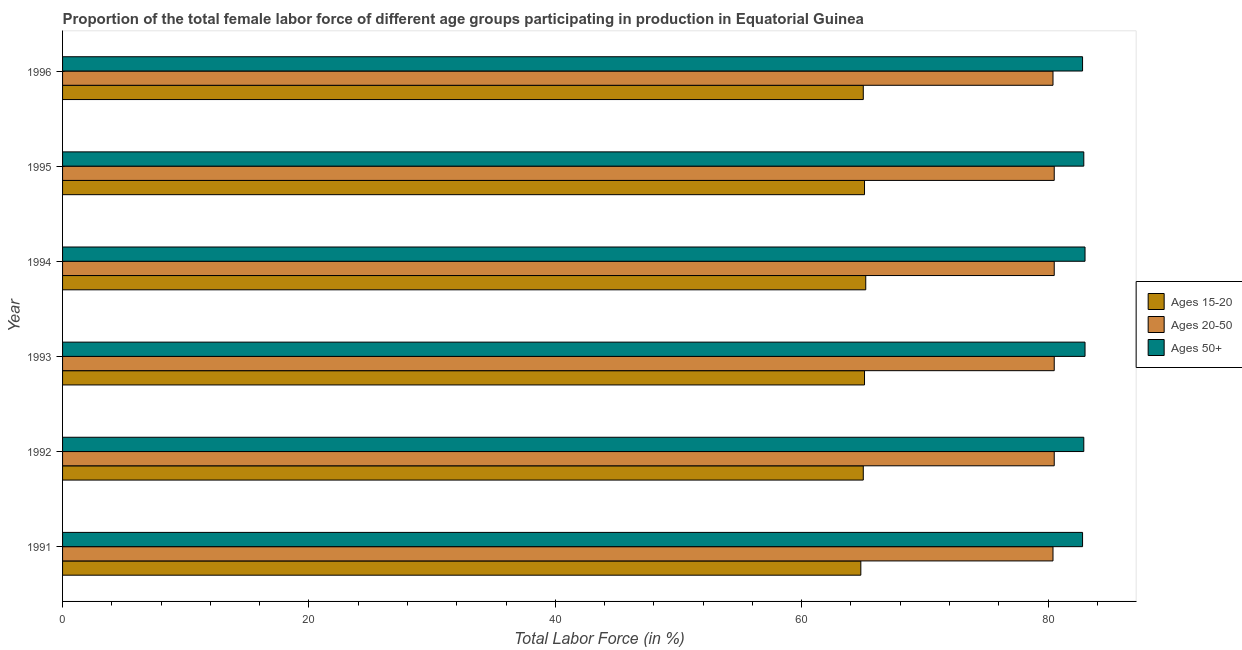How many different coloured bars are there?
Give a very brief answer. 3. How many groups of bars are there?
Keep it short and to the point. 6. Are the number of bars per tick equal to the number of legend labels?
Give a very brief answer. Yes. Are the number of bars on each tick of the Y-axis equal?
Your answer should be very brief. Yes. How many bars are there on the 2nd tick from the top?
Offer a very short reply. 3. What is the label of the 3rd group of bars from the top?
Your answer should be compact. 1994. What is the percentage of female labor force above age 50 in 1996?
Your answer should be compact. 82.8. Across all years, what is the maximum percentage of female labor force above age 50?
Keep it short and to the point. 83. Across all years, what is the minimum percentage of female labor force within the age group 20-50?
Keep it short and to the point. 80.4. In which year was the percentage of female labor force within the age group 20-50 maximum?
Offer a very short reply. 1992. What is the total percentage of female labor force within the age group 15-20 in the graph?
Offer a very short reply. 390.2. What is the difference between the percentage of female labor force within the age group 15-20 in 1991 and that in 1993?
Provide a short and direct response. -0.3. What is the difference between the percentage of female labor force within the age group 15-20 in 1991 and the percentage of female labor force above age 50 in 1993?
Your answer should be very brief. -18.2. What is the average percentage of female labor force within the age group 20-50 per year?
Keep it short and to the point. 80.47. In the year 1994, what is the difference between the percentage of female labor force within the age group 15-20 and percentage of female labor force above age 50?
Keep it short and to the point. -17.8. What is the ratio of the percentage of female labor force above age 50 in 1994 to that in 1995?
Offer a very short reply. 1. Is the difference between the percentage of female labor force within the age group 15-20 in 1994 and 1995 greater than the difference between the percentage of female labor force within the age group 20-50 in 1994 and 1995?
Make the answer very short. Yes. What is the difference between the highest and the lowest percentage of female labor force within the age group 20-50?
Provide a short and direct response. 0.1. What does the 3rd bar from the top in 1993 represents?
Offer a terse response. Ages 15-20. What does the 1st bar from the bottom in 1996 represents?
Give a very brief answer. Ages 15-20. Are all the bars in the graph horizontal?
Provide a short and direct response. Yes. How many years are there in the graph?
Make the answer very short. 6. What is the difference between two consecutive major ticks on the X-axis?
Make the answer very short. 20. Where does the legend appear in the graph?
Give a very brief answer. Center right. How many legend labels are there?
Make the answer very short. 3. What is the title of the graph?
Make the answer very short. Proportion of the total female labor force of different age groups participating in production in Equatorial Guinea. What is the Total Labor Force (in %) of Ages 15-20 in 1991?
Make the answer very short. 64.8. What is the Total Labor Force (in %) in Ages 20-50 in 1991?
Provide a succinct answer. 80.4. What is the Total Labor Force (in %) of Ages 50+ in 1991?
Your answer should be very brief. 82.8. What is the Total Labor Force (in %) in Ages 15-20 in 1992?
Your answer should be compact. 65. What is the Total Labor Force (in %) in Ages 20-50 in 1992?
Offer a very short reply. 80.5. What is the Total Labor Force (in %) in Ages 50+ in 1992?
Your answer should be very brief. 82.9. What is the Total Labor Force (in %) of Ages 15-20 in 1993?
Give a very brief answer. 65.1. What is the Total Labor Force (in %) of Ages 20-50 in 1993?
Offer a terse response. 80.5. What is the Total Labor Force (in %) in Ages 50+ in 1993?
Keep it short and to the point. 83. What is the Total Labor Force (in %) of Ages 15-20 in 1994?
Provide a short and direct response. 65.2. What is the Total Labor Force (in %) in Ages 20-50 in 1994?
Ensure brevity in your answer.  80.5. What is the Total Labor Force (in %) of Ages 50+ in 1994?
Provide a short and direct response. 83. What is the Total Labor Force (in %) of Ages 15-20 in 1995?
Your answer should be compact. 65.1. What is the Total Labor Force (in %) of Ages 20-50 in 1995?
Your answer should be compact. 80.5. What is the Total Labor Force (in %) of Ages 50+ in 1995?
Make the answer very short. 82.9. What is the Total Labor Force (in %) of Ages 20-50 in 1996?
Make the answer very short. 80.4. What is the Total Labor Force (in %) in Ages 50+ in 1996?
Your response must be concise. 82.8. Across all years, what is the maximum Total Labor Force (in %) of Ages 15-20?
Your answer should be compact. 65.2. Across all years, what is the maximum Total Labor Force (in %) in Ages 20-50?
Make the answer very short. 80.5. Across all years, what is the maximum Total Labor Force (in %) in Ages 50+?
Give a very brief answer. 83. Across all years, what is the minimum Total Labor Force (in %) of Ages 15-20?
Provide a short and direct response. 64.8. Across all years, what is the minimum Total Labor Force (in %) in Ages 20-50?
Offer a terse response. 80.4. Across all years, what is the minimum Total Labor Force (in %) of Ages 50+?
Provide a short and direct response. 82.8. What is the total Total Labor Force (in %) of Ages 15-20 in the graph?
Make the answer very short. 390.2. What is the total Total Labor Force (in %) of Ages 20-50 in the graph?
Give a very brief answer. 482.8. What is the total Total Labor Force (in %) in Ages 50+ in the graph?
Offer a very short reply. 497.4. What is the difference between the Total Labor Force (in %) of Ages 50+ in 1991 and that in 1992?
Offer a very short reply. -0.1. What is the difference between the Total Labor Force (in %) in Ages 50+ in 1991 and that in 1993?
Give a very brief answer. -0.2. What is the difference between the Total Labor Force (in %) in Ages 15-20 in 1991 and that in 1994?
Offer a very short reply. -0.4. What is the difference between the Total Labor Force (in %) of Ages 50+ in 1991 and that in 1994?
Offer a very short reply. -0.2. What is the difference between the Total Labor Force (in %) in Ages 15-20 in 1991 and that in 1996?
Provide a succinct answer. -0.2. What is the difference between the Total Labor Force (in %) in Ages 20-50 in 1991 and that in 1996?
Offer a very short reply. 0. What is the difference between the Total Labor Force (in %) of Ages 50+ in 1991 and that in 1996?
Your answer should be very brief. 0. What is the difference between the Total Labor Force (in %) in Ages 15-20 in 1992 and that in 1993?
Your answer should be very brief. -0.1. What is the difference between the Total Labor Force (in %) in Ages 15-20 in 1992 and that in 1994?
Offer a terse response. -0.2. What is the difference between the Total Labor Force (in %) in Ages 20-50 in 1992 and that in 1994?
Ensure brevity in your answer.  0. What is the difference between the Total Labor Force (in %) in Ages 50+ in 1992 and that in 1994?
Your response must be concise. -0.1. What is the difference between the Total Labor Force (in %) of Ages 15-20 in 1992 and that in 1995?
Your response must be concise. -0.1. What is the difference between the Total Labor Force (in %) of Ages 20-50 in 1992 and that in 1995?
Provide a short and direct response. 0. What is the difference between the Total Labor Force (in %) of Ages 50+ in 1992 and that in 1995?
Offer a very short reply. 0. What is the difference between the Total Labor Force (in %) in Ages 15-20 in 1992 and that in 1996?
Offer a terse response. 0. What is the difference between the Total Labor Force (in %) of Ages 50+ in 1993 and that in 1995?
Your answer should be compact. 0.1. What is the difference between the Total Labor Force (in %) in Ages 15-20 in 1993 and that in 1996?
Offer a very short reply. 0.1. What is the difference between the Total Labor Force (in %) in Ages 20-50 in 1993 and that in 1996?
Keep it short and to the point. 0.1. What is the difference between the Total Labor Force (in %) of Ages 20-50 in 1994 and that in 1995?
Your answer should be compact. 0. What is the difference between the Total Labor Force (in %) of Ages 50+ in 1994 and that in 1996?
Provide a succinct answer. 0.2. What is the difference between the Total Labor Force (in %) of Ages 20-50 in 1995 and that in 1996?
Keep it short and to the point. 0.1. What is the difference between the Total Labor Force (in %) of Ages 50+ in 1995 and that in 1996?
Provide a succinct answer. 0.1. What is the difference between the Total Labor Force (in %) of Ages 15-20 in 1991 and the Total Labor Force (in %) of Ages 20-50 in 1992?
Offer a terse response. -15.7. What is the difference between the Total Labor Force (in %) in Ages 15-20 in 1991 and the Total Labor Force (in %) in Ages 50+ in 1992?
Ensure brevity in your answer.  -18.1. What is the difference between the Total Labor Force (in %) in Ages 15-20 in 1991 and the Total Labor Force (in %) in Ages 20-50 in 1993?
Your response must be concise. -15.7. What is the difference between the Total Labor Force (in %) in Ages 15-20 in 1991 and the Total Labor Force (in %) in Ages 50+ in 1993?
Ensure brevity in your answer.  -18.2. What is the difference between the Total Labor Force (in %) in Ages 15-20 in 1991 and the Total Labor Force (in %) in Ages 20-50 in 1994?
Ensure brevity in your answer.  -15.7. What is the difference between the Total Labor Force (in %) of Ages 15-20 in 1991 and the Total Labor Force (in %) of Ages 50+ in 1994?
Make the answer very short. -18.2. What is the difference between the Total Labor Force (in %) of Ages 15-20 in 1991 and the Total Labor Force (in %) of Ages 20-50 in 1995?
Provide a succinct answer. -15.7. What is the difference between the Total Labor Force (in %) of Ages 15-20 in 1991 and the Total Labor Force (in %) of Ages 50+ in 1995?
Your response must be concise. -18.1. What is the difference between the Total Labor Force (in %) in Ages 15-20 in 1991 and the Total Labor Force (in %) in Ages 20-50 in 1996?
Keep it short and to the point. -15.6. What is the difference between the Total Labor Force (in %) of Ages 20-50 in 1991 and the Total Labor Force (in %) of Ages 50+ in 1996?
Keep it short and to the point. -2.4. What is the difference between the Total Labor Force (in %) of Ages 15-20 in 1992 and the Total Labor Force (in %) of Ages 20-50 in 1993?
Offer a very short reply. -15.5. What is the difference between the Total Labor Force (in %) in Ages 20-50 in 1992 and the Total Labor Force (in %) in Ages 50+ in 1993?
Keep it short and to the point. -2.5. What is the difference between the Total Labor Force (in %) of Ages 15-20 in 1992 and the Total Labor Force (in %) of Ages 20-50 in 1994?
Provide a succinct answer. -15.5. What is the difference between the Total Labor Force (in %) in Ages 20-50 in 1992 and the Total Labor Force (in %) in Ages 50+ in 1994?
Give a very brief answer. -2.5. What is the difference between the Total Labor Force (in %) of Ages 15-20 in 1992 and the Total Labor Force (in %) of Ages 20-50 in 1995?
Make the answer very short. -15.5. What is the difference between the Total Labor Force (in %) in Ages 15-20 in 1992 and the Total Labor Force (in %) in Ages 50+ in 1995?
Your answer should be very brief. -17.9. What is the difference between the Total Labor Force (in %) in Ages 15-20 in 1992 and the Total Labor Force (in %) in Ages 20-50 in 1996?
Provide a short and direct response. -15.4. What is the difference between the Total Labor Force (in %) of Ages 15-20 in 1992 and the Total Labor Force (in %) of Ages 50+ in 1996?
Provide a succinct answer. -17.8. What is the difference between the Total Labor Force (in %) of Ages 15-20 in 1993 and the Total Labor Force (in %) of Ages 20-50 in 1994?
Provide a short and direct response. -15.4. What is the difference between the Total Labor Force (in %) of Ages 15-20 in 1993 and the Total Labor Force (in %) of Ages 50+ in 1994?
Keep it short and to the point. -17.9. What is the difference between the Total Labor Force (in %) of Ages 15-20 in 1993 and the Total Labor Force (in %) of Ages 20-50 in 1995?
Your answer should be very brief. -15.4. What is the difference between the Total Labor Force (in %) in Ages 15-20 in 1993 and the Total Labor Force (in %) in Ages 50+ in 1995?
Keep it short and to the point. -17.8. What is the difference between the Total Labor Force (in %) of Ages 20-50 in 1993 and the Total Labor Force (in %) of Ages 50+ in 1995?
Ensure brevity in your answer.  -2.4. What is the difference between the Total Labor Force (in %) of Ages 15-20 in 1993 and the Total Labor Force (in %) of Ages 20-50 in 1996?
Offer a very short reply. -15.3. What is the difference between the Total Labor Force (in %) of Ages 15-20 in 1993 and the Total Labor Force (in %) of Ages 50+ in 1996?
Your answer should be compact. -17.7. What is the difference between the Total Labor Force (in %) of Ages 20-50 in 1993 and the Total Labor Force (in %) of Ages 50+ in 1996?
Make the answer very short. -2.3. What is the difference between the Total Labor Force (in %) of Ages 15-20 in 1994 and the Total Labor Force (in %) of Ages 20-50 in 1995?
Offer a very short reply. -15.3. What is the difference between the Total Labor Force (in %) of Ages 15-20 in 1994 and the Total Labor Force (in %) of Ages 50+ in 1995?
Make the answer very short. -17.7. What is the difference between the Total Labor Force (in %) of Ages 15-20 in 1994 and the Total Labor Force (in %) of Ages 20-50 in 1996?
Keep it short and to the point. -15.2. What is the difference between the Total Labor Force (in %) of Ages 15-20 in 1994 and the Total Labor Force (in %) of Ages 50+ in 1996?
Provide a short and direct response. -17.6. What is the difference between the Total Labor Force (in %) in Ages 15-20 in 1995 and the Total Labor Force (in %) in Ages 20-50 in 1996?
Your answer should be compact. -15.3. What is the difference between the Total Labor Force (in %) of Ages 15-20 in 1995 and the Total Labor Force (in %) of Ages 50+ in 1996?
Make the answer very short. -17.7. What is the difference between the Total Labor Force (in %) of Ages 20-50 in 1995 and the Total Labor Force (in %) of Ages 50+ in 1996?
Make the answer very short. -2.3. What is the average Total Labor Force (in %) in Ages 15-20 per year?
Your answer should be very brief. 65.03. What is the average Total Labor Force (in %) in Ages 20-50 per year?
Provide a short and direct response. 80.47. What is the average Total Labor Force (in %) of Ages 50+ per year?
Keep it short and to the point. 82.9. In the year 1991, what is the difference between the Total Labor Force (in %) of Ages 15-20 and Total Labor Force (in %) of Ages 20-50?
Provide a succinct answer. -15.6. In the year 1992, what is the difference between the Total Labor Force (in %) of Ages 15-20 and Total Labor Force (in %) of Ages 20-50?
Your response must be concise. -15.5. In the year 1992, what is the difference between the Total Labor Force (in %) in Ages 15-20 and Total Labor Force (in %) in Ages 50+?
Your answer should be compact. -17.9. In the year 1992, what is the difference between the Total Labor Force (in %) in Ages 20-50 and Total Labor Force (in %) in Ages 50+?
Make the answer very short. -2.4. In the year 1993, what is the difference between the Total Labor Force (in %) in Ages 15-20 and Total Labor Force (in %) in Ages 20-50?
Give a very brief answer. -15.4. In the year 1993, what is the difference between the Total Labor Force (in %) in Ages 15-20 and Total Labor Force (in %) in Ages 50+?
Offer a very short reply. -17.9. In the year 1994, what is the difference between the Total Labor Force (in %) in Ages 15-20 and Total Labor Force (in %) in Ages 20-50?
Your response must be concise. -15.3. In the year 1994, what is the difference between the Total Labor Force (in %) in Ages 15-20 and Total Labor Force (in %) in Ages 50+?
Offer a very short reply. -17.8. In the year 1995, what is the difference between the Total Labor Force (in %) in Ages 15-20 and Total Labor Force (in %) in Ages 20-50?
Provide a short and direct response. -15.4. In the year 1995, what is the difference between the Total Labor Force (in %) in Ages 15-20 and Total Labor Force (in %) in Ages 50+?
Make the answer very short. -17.8. In the year 1996, what is the difference between the Total Labor Force (in %) of Ages 15-20 and Total Labor Force (in %) of Ages 20-50?
Your answer should be very brief. -15.4. In the year 1996, what is the difference between the Total Labor Force (in %) in Ages 15-20 and Total Labor Force (in %) in Ages 50+?
Keep it short and to the point. -17.8. In the year 1996, what is the difference between the Total Labor Force (in %) in Ages 20-50 and Total Labor Force (in %) in Ages 50+?
Offer a very short reply. -2.4. What is the ratio of the Total Labor Force (in %) in Ages 15-20 in 1991 to that in 1992?
Make the answer very short. 1. What is the ratio of the Total Labor Force (in %) in Ages 15-20 in 1991 to that in 1993?
Your response must be concise. 1. What is the ratio of the Total Labor Force (in %) in Ages 20-50 in 1991 to that in 1993?
Offer a very short reply. 1. What is the ratio of the Total Labor Force (in %) of Ages 50+ in 1991 to that in 1993?
Offer a terse response. 1. What is the ratio of the Total Labor Force (in %) in Ages 50+ in 1991 to that in 1995?
Ensure brevity in your answer.  1. What is the ratio of the Total Labor Force (in %) of Ages 15-20 in 1991 to that in 1996?
Keep it short and to the point. 1. What is the ratio of the Total Labor Force (in %) in Ages 20-50 in 1991 to that in 1996?
Ensure brevity in your answer.  1. What is the ratio of the Total Labor Force (in %) of Ages 15-20 in 1992 to that in 1995?
Ensure brevity in your answer.  1. What is the ratio of the Total Labor Force (in %) in Ages 20-50 in 1992 to that in 1995?
Keep it short and to the point. 1. What is the ratio of the Total Labor Force (in %) in Ages 50+ in 1992 to that in 1995?
Your answer should be very brief. 1. What is the ratio of the Total Labor Force (in %) of Ages 15-20 in 1992 to that in 1996?
Make the answer very short. 1. What is the ratio of the Total Labor Force (in %) of Ages 15-20 in 1993 to that in 1994?
Your response must be concise. 1. What is the ratio of the Total Labor Force (in %) of Ages 20-50 in 1993 to that in 1994?
Give a very brief answer. 1. What is the ratio of the Total Labor Force (in %) in Ages 50+ in 1993 to that in 1994?
Offer a terse response. 1. What is the ratio of the Total Labor Force (in %) of Ages 20-50 in 1993 to that in 1995?
Make the answer very short. 1. What is the ratio of the Total Labor Force (in %) of Ages 20-50 in 1993 to that in 1996?
Offer a terse response. 1. What is the ratio of the Total Labor Force (in %) of Ages 50+ in 1994 to that in 1995?
Your answer should be very brief. 1. What is the ratio of the Total Labor Force (in %) of Ages 15-20 in 1994 to that in 1996?
Your answer should be very brief. 1. What is the ratio of the Total Labor Force (in %) in Ages 20-50 in 1994 to that in 1996?
Keep it short and to the point. 1. What is the ratio of the Total Labor Force (in %) in Ages 50+ in 1994 to that in 1996?
Keep it short and to the point. 1. What is the ratio of the Total Labor Force (in %) of Ages 20-50 in 1995 to that in 1996?
Make the answer very short. 1. What is the difference between the highest and the second highest Total Labor Force (in %) in Ages 20-50?
Your answer should be very brief. 0. What is the difference between the highest and the second highest Total Labor Force (in %) in Ages 50+?
Give a very brief answer. 0. What is the difference between the highest and the lowest Total Labor Force (in %) of Ages 15-20?
Provide a short and direct response. 0.4. What is the difference between the highest and the lowest Total Labor Force (in %) of Ages 20-50?
Give a very brief answer. 0.1. What is the difference between the highest and the lowest Total Labor Force (in %) in Ages 50+?
Provide a short and direct response. 0.2. 